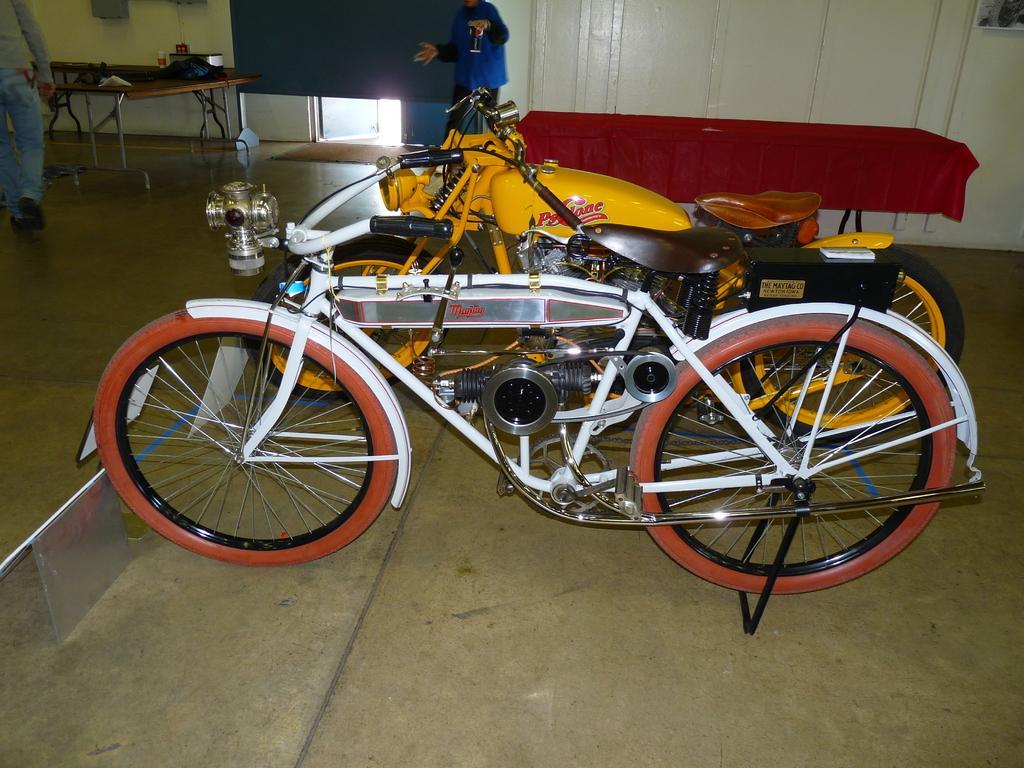In one or two sentences, can you explain what this image depicts? There are two motor vehicles and there is a table with a red cloth on it and there are two persons standing in front of it. 